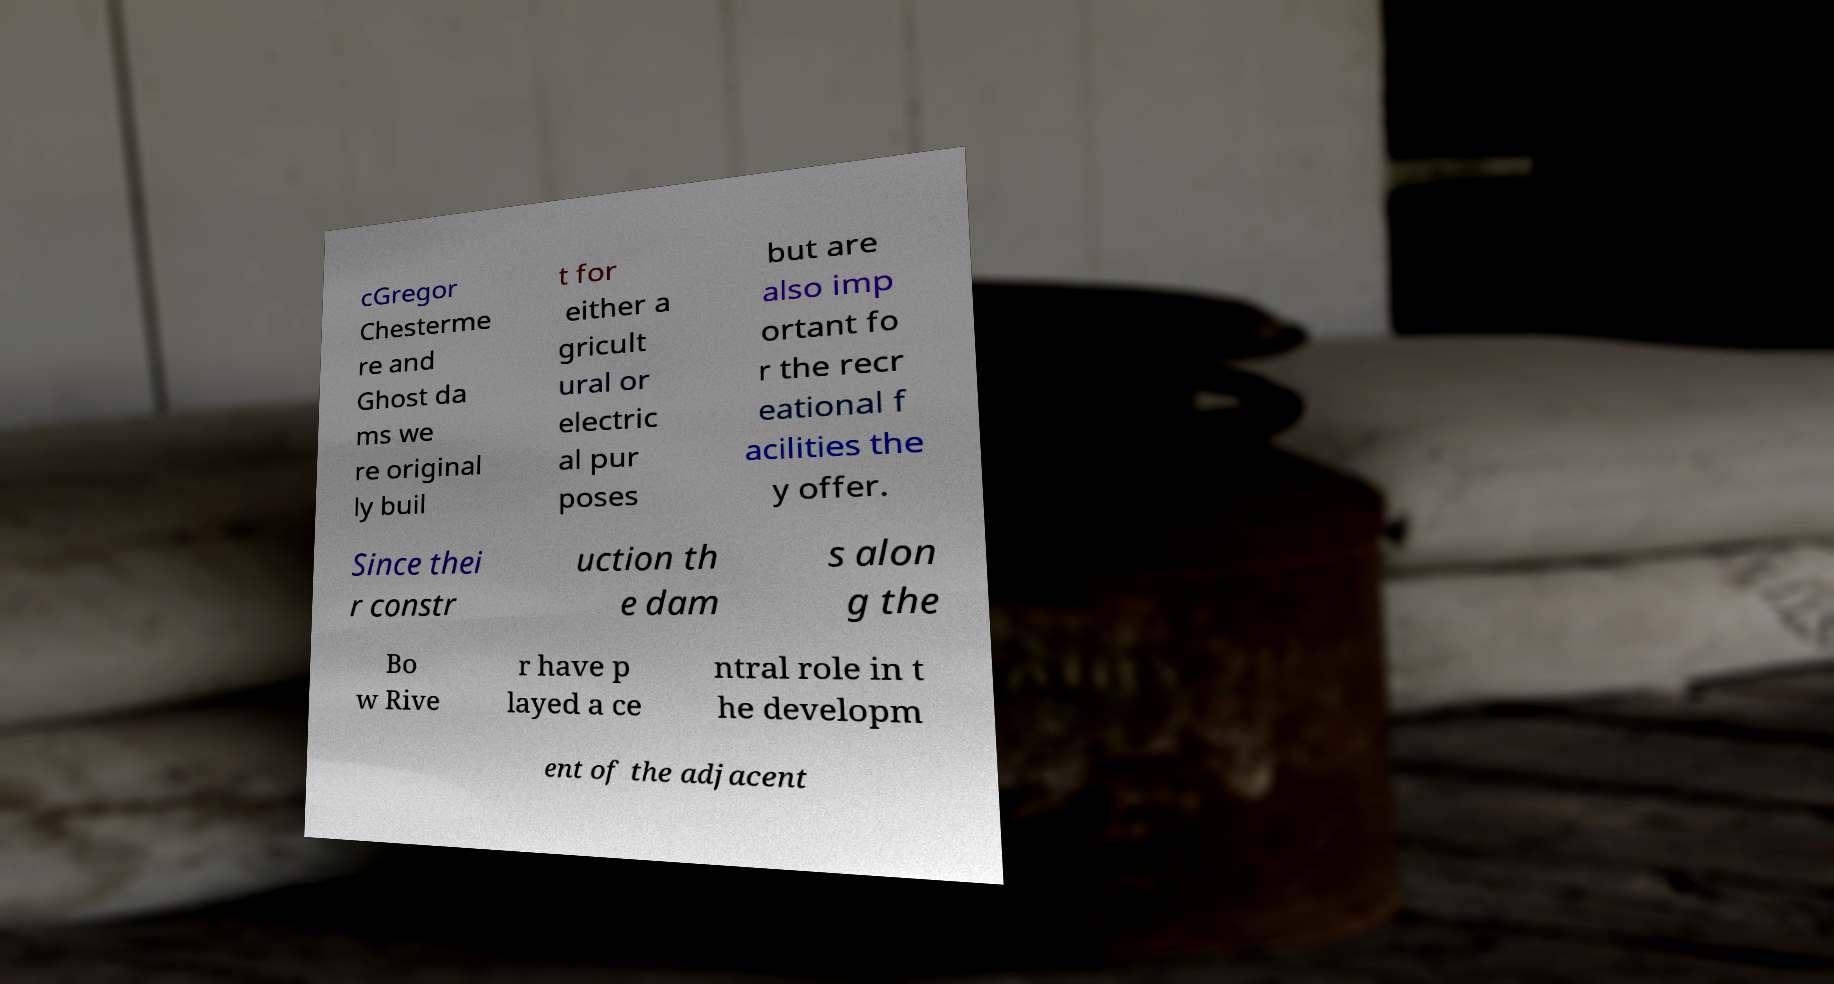There's text embedded in this image that I need extracted. Can you transcribe it verbatim? cGregor Chesterme re and Ghost da ms we re original ly buil t for either a gricult ural or electric al pur poses but are also imp ortant fo r the recr eational f acilities the y offer. Since thei r constr uction th e dam s alon g the Bo w Rive r have p layed a ce ntral role in t he developm ent of the adjacent 